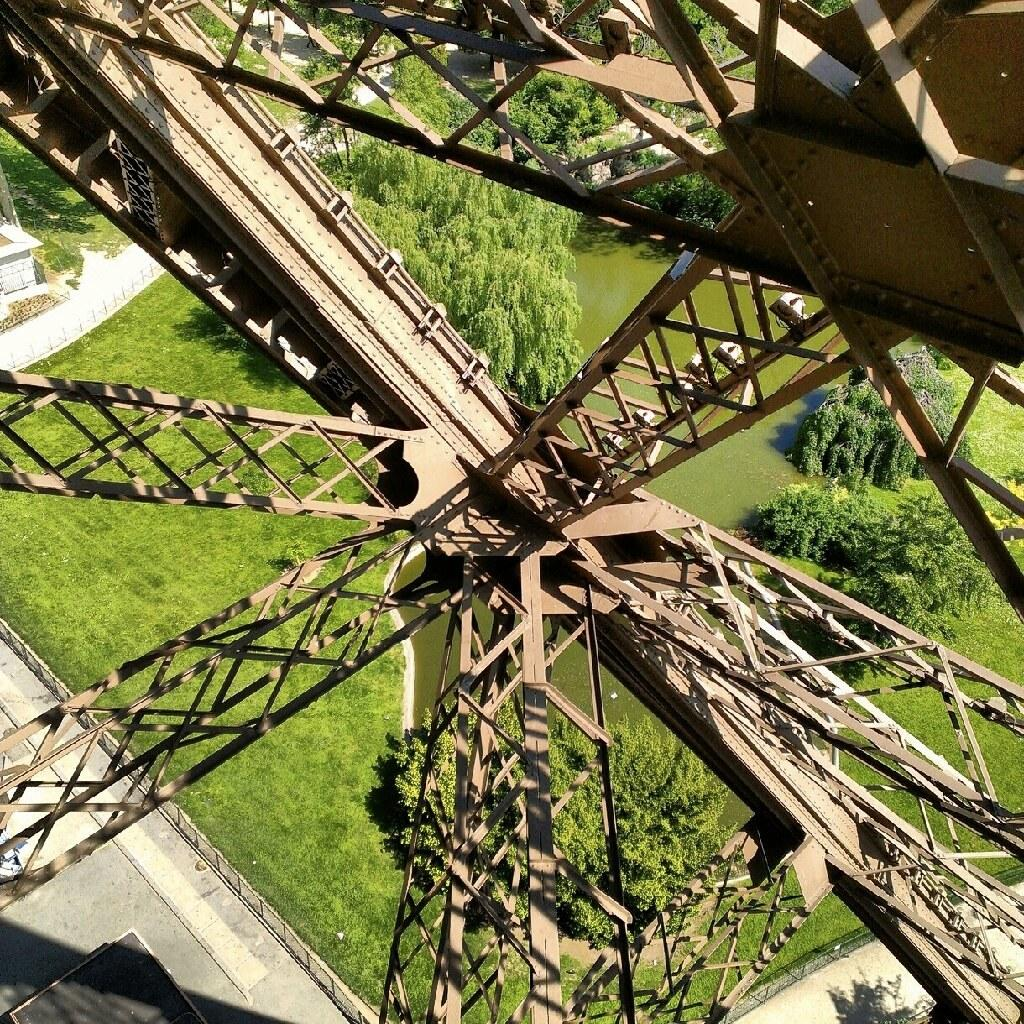What type of objects can be seen in the image? There are iron rods in the image. What can be found at the bottom of the image? There are trees, grass, and water visible at the bottom of the image. What type of income can be seen hanging from the trees in the image? There is no income visible in the image, as income is a financial concept and not a physical object. 